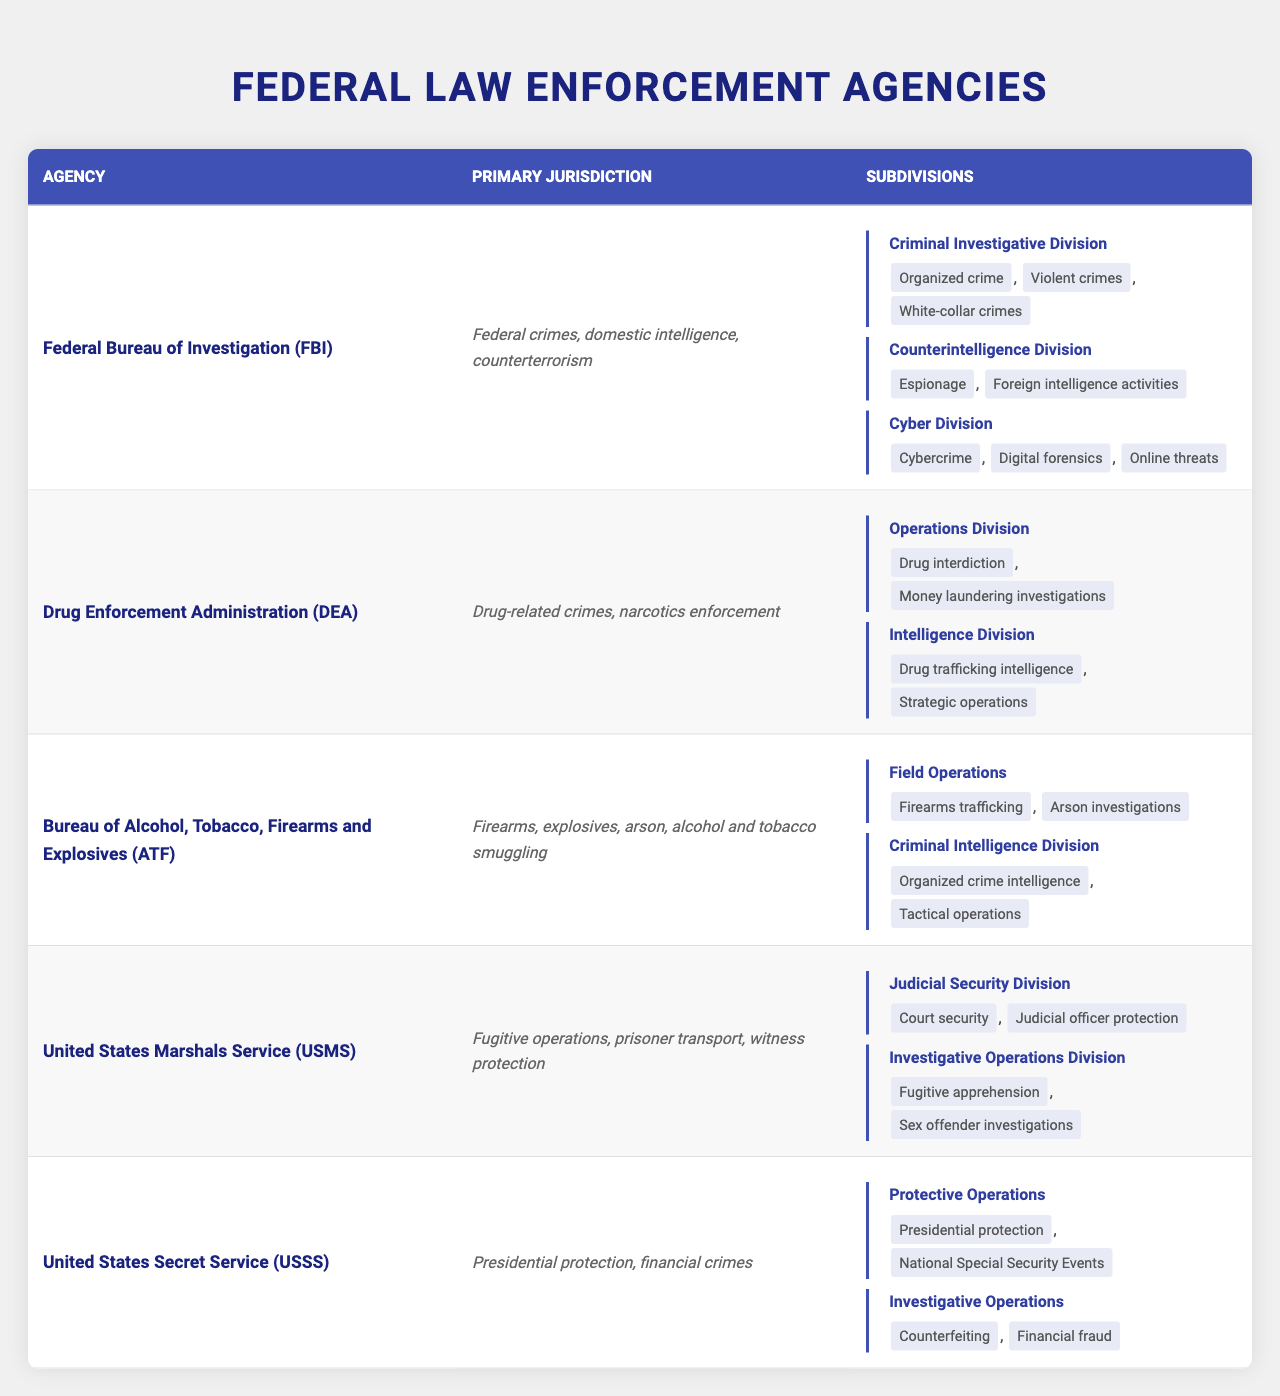What is the primary jurisdiction of the Drug Enforcement Administration (DEA)? The table shows that the DEA has a primary jurisdiction over drug-related crimes and narcotics enforcement, which is explicitly stated in the row for the DEA.
Answer: Drug-related crimes, narcotics enforcement How many subdivisions does the FBI have? The table lists three subdivisions under the FBI: Criminal Investigative Division, Counterintelligence Division, and Cyber Division, making it easy to count.
Answer: 3 Which agency focuses on firearms and explosives? By scanning the table, it is clear that the Bureau of Alcohol, Tobacco, Firearms and Explosives (ATF) is the agency that focuses on firearms and explosives.
Answer: Bureau of Alcohol, Tobacco, Firearms and Explosives (ATF) What areas does the Cyber Division of the FBI focus on? The table specifies that the Cyber Division focuses on cybercrime, digital forensics, and online threats, listed under the FBI's subdivisions.
Answer: Cybercrime, digital forensics, online threats Which agency is responsible for presidential protection? According to the table, the United States Secret Service (USSS) is the agency responsible for presidential protection, as its primary jurisdiction includes this responsibility.
Answer: United States Secret Service (USSS) Are organized crime and violent crimes focus areas for the Counterintelligence Division? A review of the table indicates that the Counterintelligence Division focuses on espionage and foreign intelligence activities, not on organized crime or violent crimes.
Answer: No Which agency has more subdivisions, the DEA or ATF? By examining the subdivisions listed for each agency, the DEA has two subdivisions, while the ATF also has two subdivisions, showing that they have the same number of subdivisions.
Answer: They have the same number of subdivisions What is the focus area of the Protective Operations subdivision of the US Secret Service? The table indicates that the Protective Operations subdivision focuses on presidential protection and National Special Security Events, both specifically listed in its focus areas.
Answer: Presidential protection, National Special Security Events If we count the total number of focus areas for the FBI, how many do we have? The FBI has three subdivisions, each with specific focus areas: Criminal Investigative Division (3 areas), Counterintelligence Division (2 areas), and Cyber Division (3 areas). Therefore, total focus areas are 3 + 2 + 3 = 8.
Answer: 8 Which agency operates in both narcotics enforcement and financial crimes? Based on the table, the DEA primarily focuses on narcotics enforcement, while the United States Secret Service focuses on financial crimes. Therefore, no single agency operates in both specific areas.
Answer: No agency operates in both 